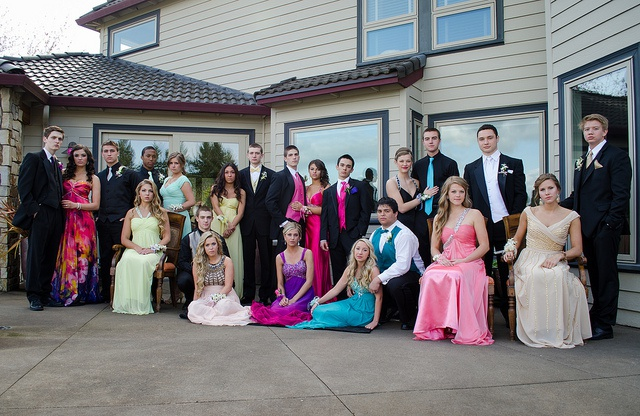Describe the objects in this image and their specific colors. I can see people in white, black, darkgray, and gray tones, people in white, lightpink, violet, pink, and darkgray tones, people in white, darkgray, lightgray, and gray tones, people in white, black, darkgray, and gray tones, and people in white, black, gray, and darkgray tones in this image. 